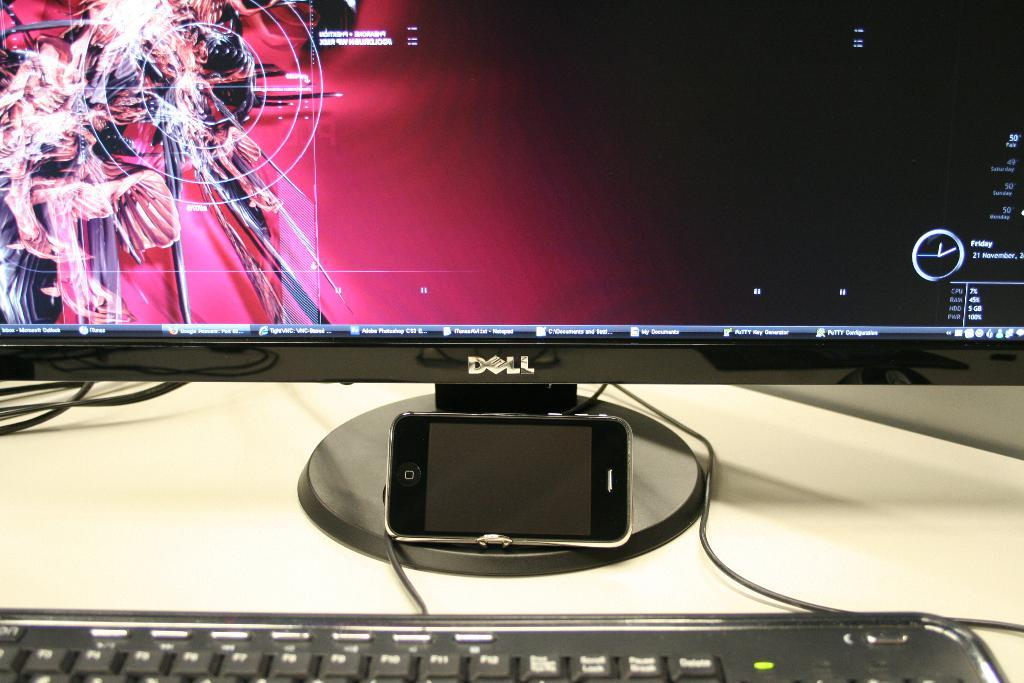Provide a one-sentence caption for the provided image. A dell computer showing a screen with a pink background and information and a keyboard in front of the screen. 